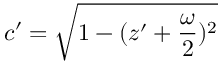<formula> <loc_0><loc_0><loc_500><loc_500>c ^ { \prime } = \sqrt { 1 - ( z ^ { \prime } + \frac { \omega } { 2 } ) ^ { 2 } }</formula> 